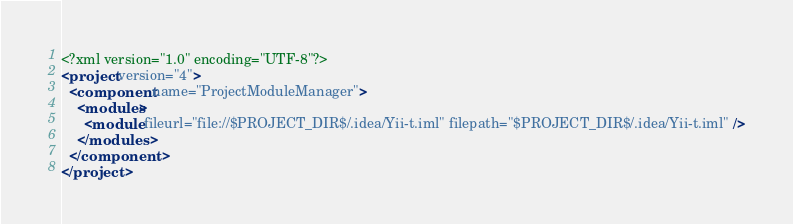<code> <loc_0><loc_0><loc_500><loc_500><_XML_><?xml version="1.0" encoding="UTF-8"?>
<project version="4">
  <component name="ProjectModuleManager">
    <modules>
      <module fileurl="file://$PROJECT_DIR$/.idea/Yii-t.iml" filepath="$PROJECT_DIR$/.idea/Yii-t.iml" />
    </modules>
  </component>
</project></code> 